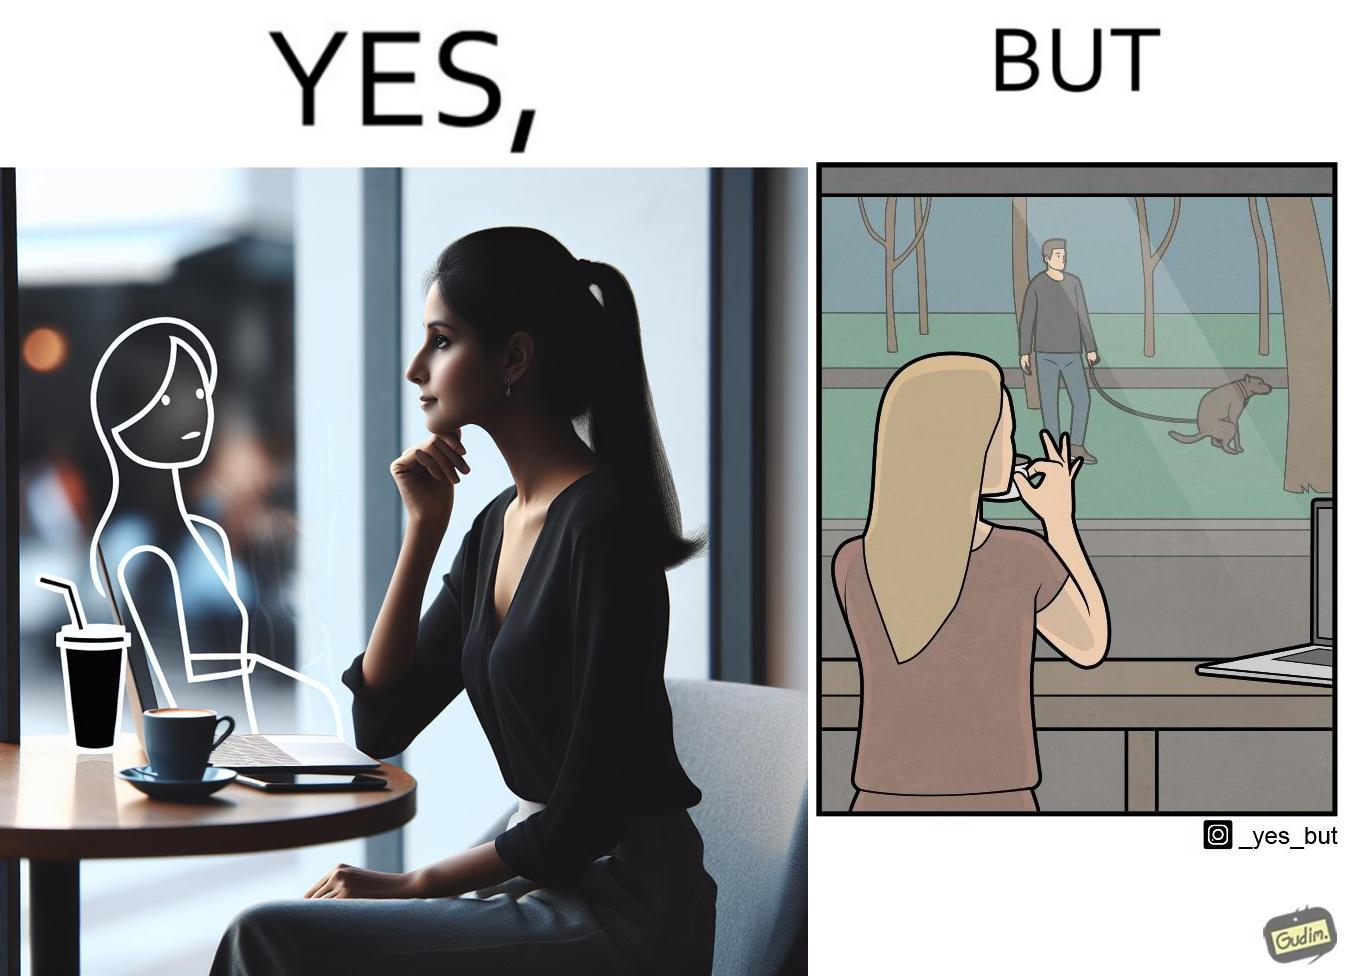What is shown in the left half versus the right half of this image? In the left part of the image: a woman looking through the window from a cafe while enjoying her drink with working on her laptop In the right part of the image: a woman enjoying her drink and working at laptop while looking outside through the window at a person who is out for getting his dog pooped outside 